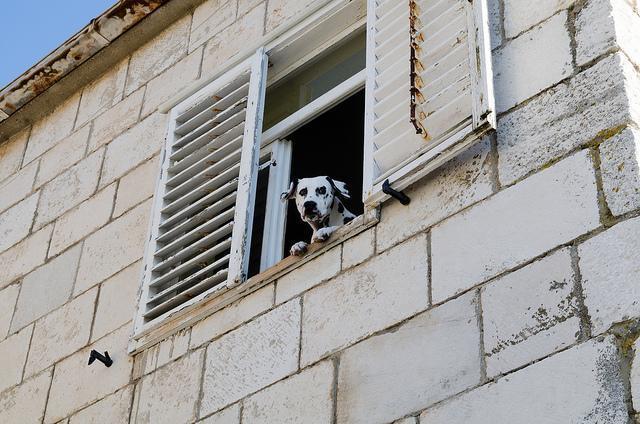How many toilets have a colored seat?
Give a very brief answer. 0. 